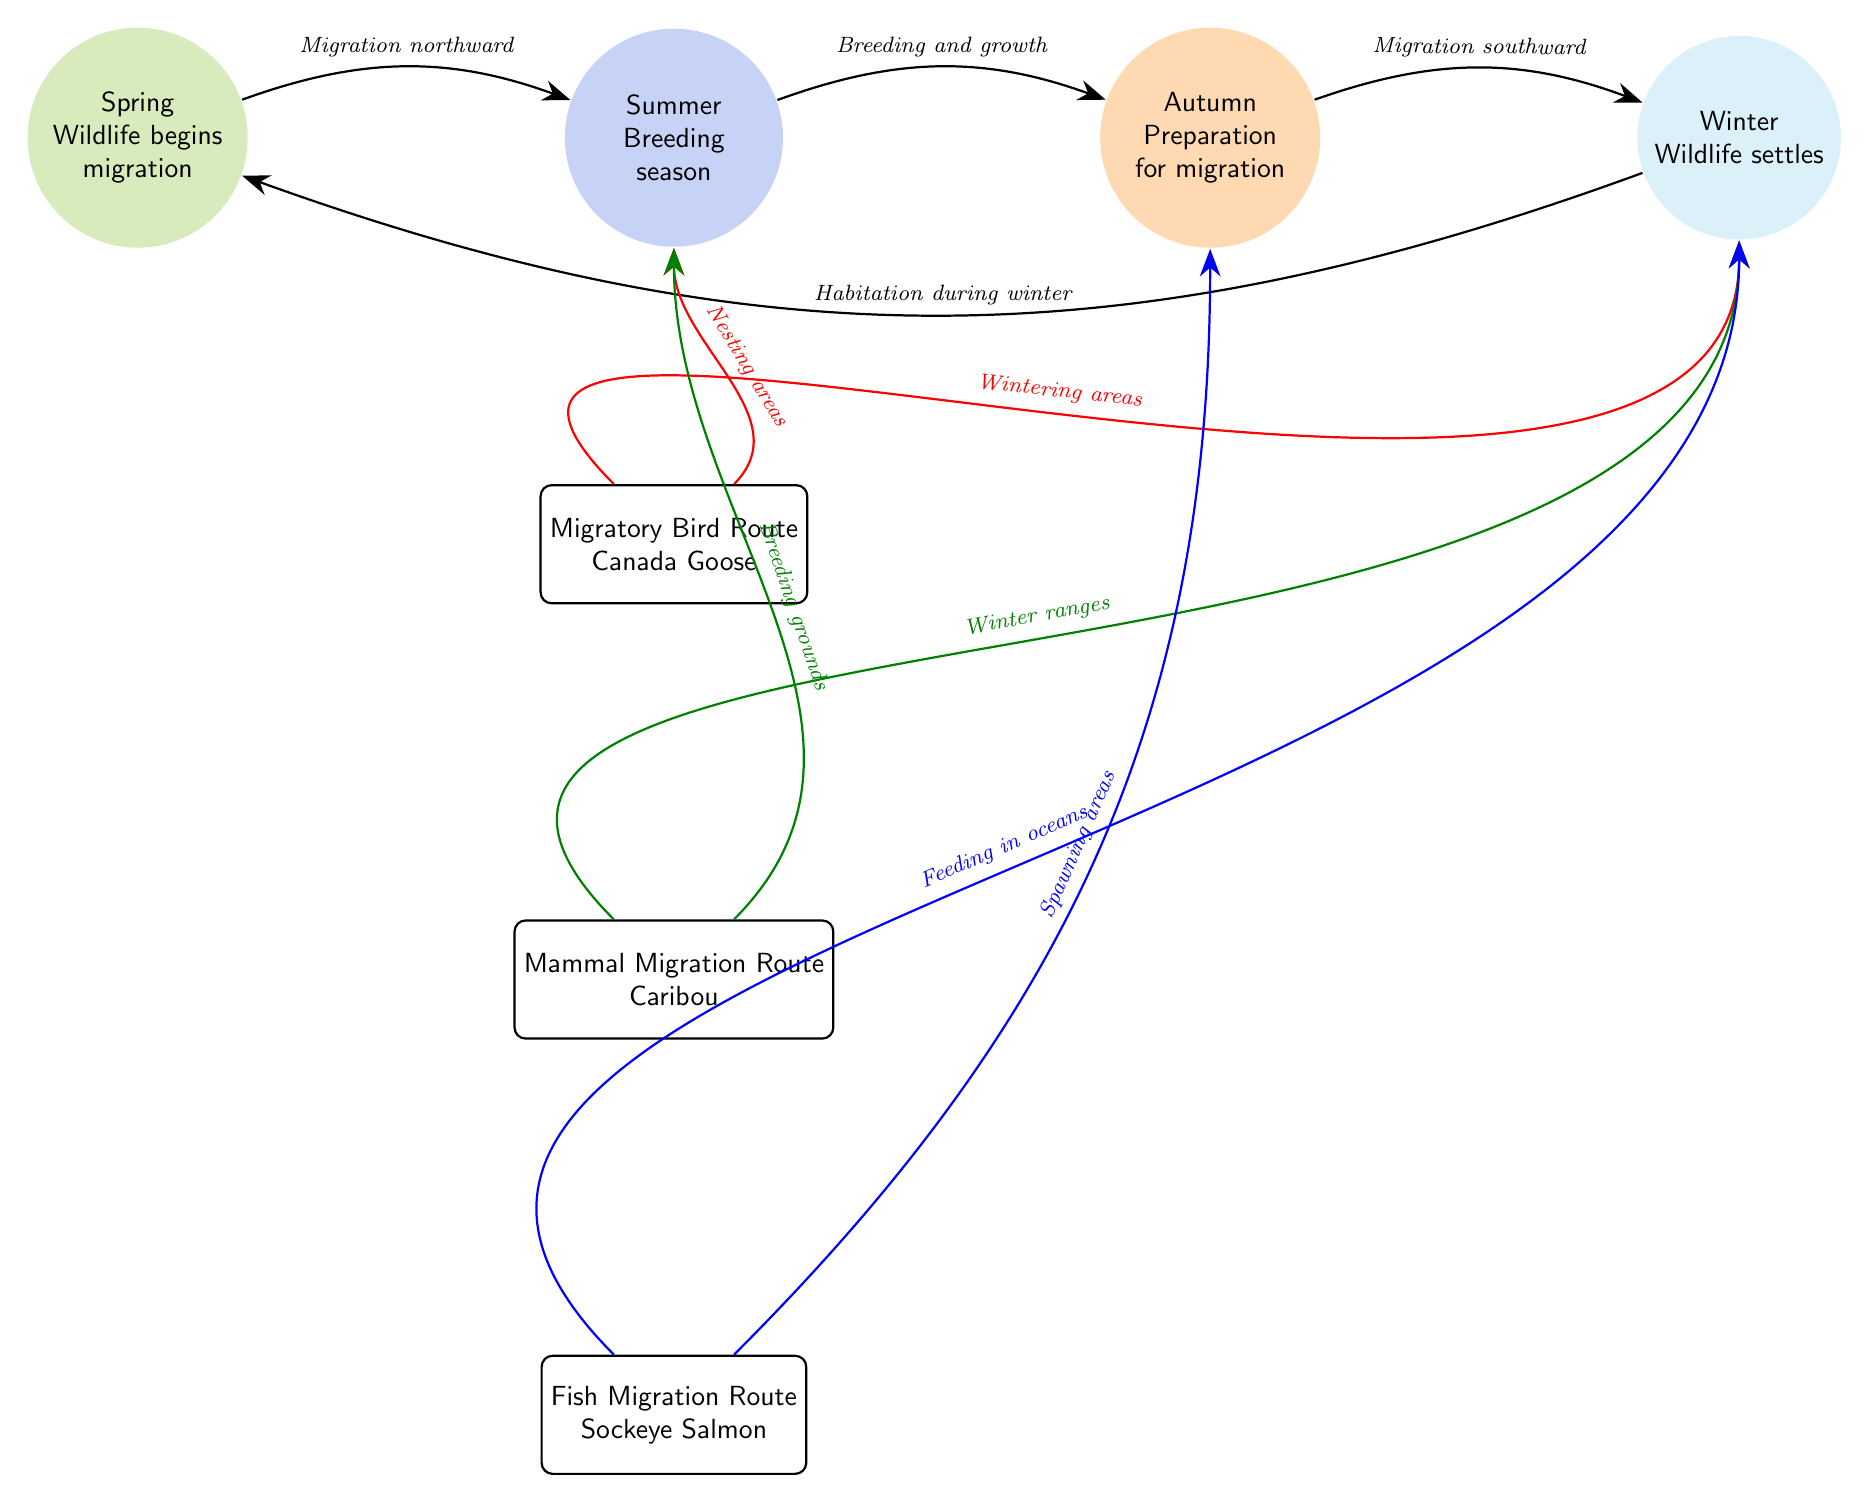What are the four seasons listed in the diagram? The diagram clearly identifies four distinct seasons: Spring, Summer, Autumn, and Winter. Each season is represented within a circular node labeled accordingly.
Answer: Spring, Summer, Autumn, Winter Which route is associated with Canada Goose? In the diagram, there is a specific route labeled "Migratory Bird Route," which identifies the migration path associated with Canada Goose.
Answer: Migratory Bird Route What does the arrow from Spring to Summer indicate? The arrow connecting the Spring node to the Summer node has a label indicating "Migration northward," which describes the movement of wildlife as they transition from Spring to Summer.
Answer: Migration northward How many migratory routes are displayed? The diagram features three distinct migratory routes represented by individual rectangular nodes, specifically for birds, mammals, and fish. Therefore, the total count of routes is three.
Answer: 3 What season precedes Winter? The diagram shows that Autumn is positioned directly before Winter in the flow of seasonal events, indicating the timing of the migratory cycles.
Answer: Autumn What is indicated by the arrow moving from Mammal Migration Route to Summer? The arrow from the Mammal Migration Route to the Summer node is labeled "Breeding grounds," indicating where mammals will breed during this season after migration.
Answer: Breeding grounds What are the two areas indicated for Sockeye Salmon during Winter? The arrow from the Fish Migration Route to the Winter node is labeled "Feeding in oceans," and the arrow directed downwards from the same route indicates "Spawning areas" leading to Autumn, indicating these two critical areas for Sockeye Salmon during Winter.
Answer: Feeding in oceans, Spawning areas What sequence is indicated by the arrows connecting the seasonal nodes? The arrows suggest a cyclical flow reflecting the patterns of wildlife movement: Spring to Summer indicates migration, Summer to Autumn denotes breeding and growth, Autumn to Winter symbolizes migration Southward, and Winter returning to Spring reflects habitation.
Answer: Spring to Summer to Autumn to Winter What does the arrow from Winter to Spring signify? This arrow indicates "Habitation during winter," suggesting that wildlife settle during Winter before migrating back as the cycles flow into Spring once again.
Answer: Habitation during winter 